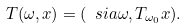Convert formula to latex. <formula><loc_0><loc_0><loc_500><loc_500>T ( \omega , x ) = ( \ s i a \omega , T _ { \omega _ { 0 } } x ) .</formula> 